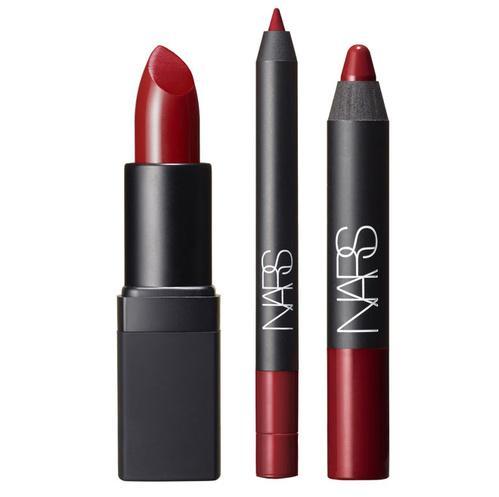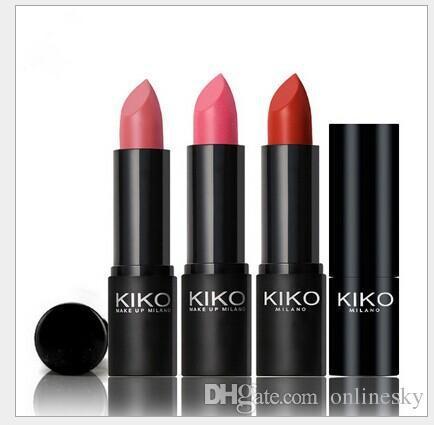The first image is the image on the left, the second image is the image on the right. Examine the images to the left and right. Is the description "An image with three lip cosmetics includes at least one product shaped like a crayon." accurate? Answer yes or no. Yes. 